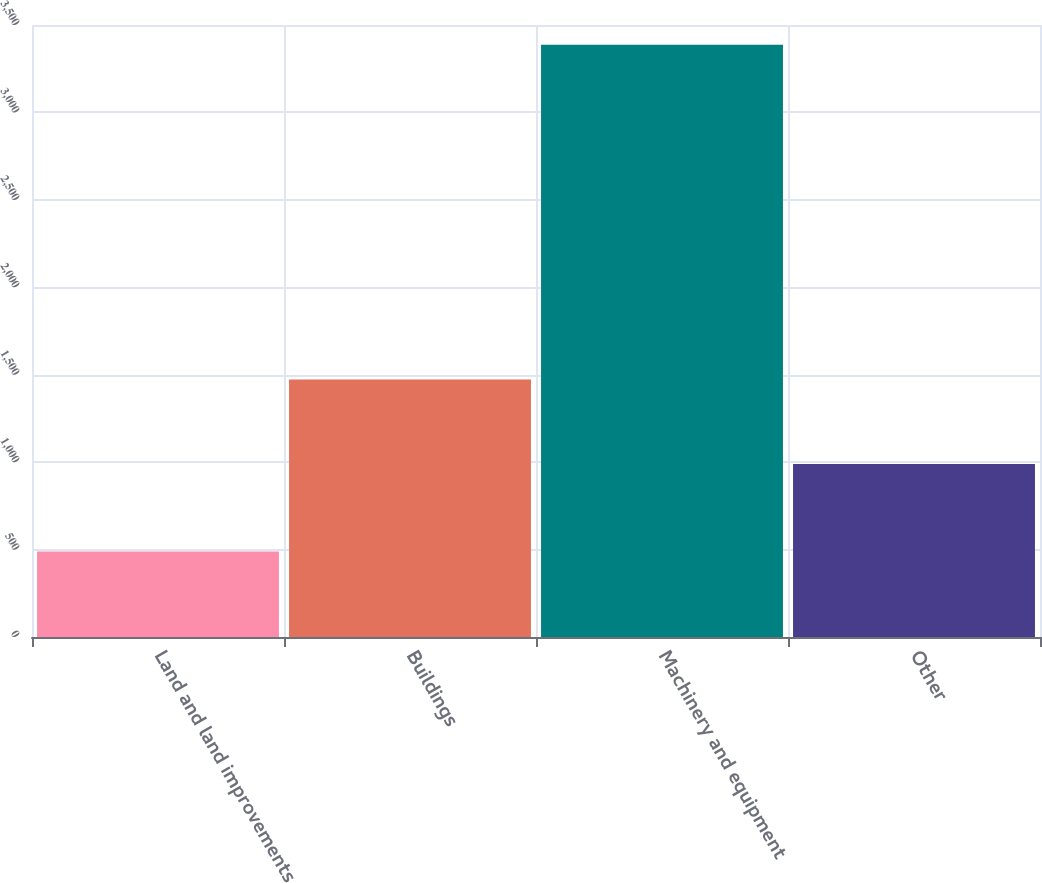Convert chart. <chart><loc_0><loc_0><loc_500><loc_500><bar_chart><fcel>Land and land improvements<fcel>Buildings<fcel>Machinery and equipment<fcel>Other<nl><fcel>489<fcel>1472<fcel>3387<fcel>989<nl></chart> 